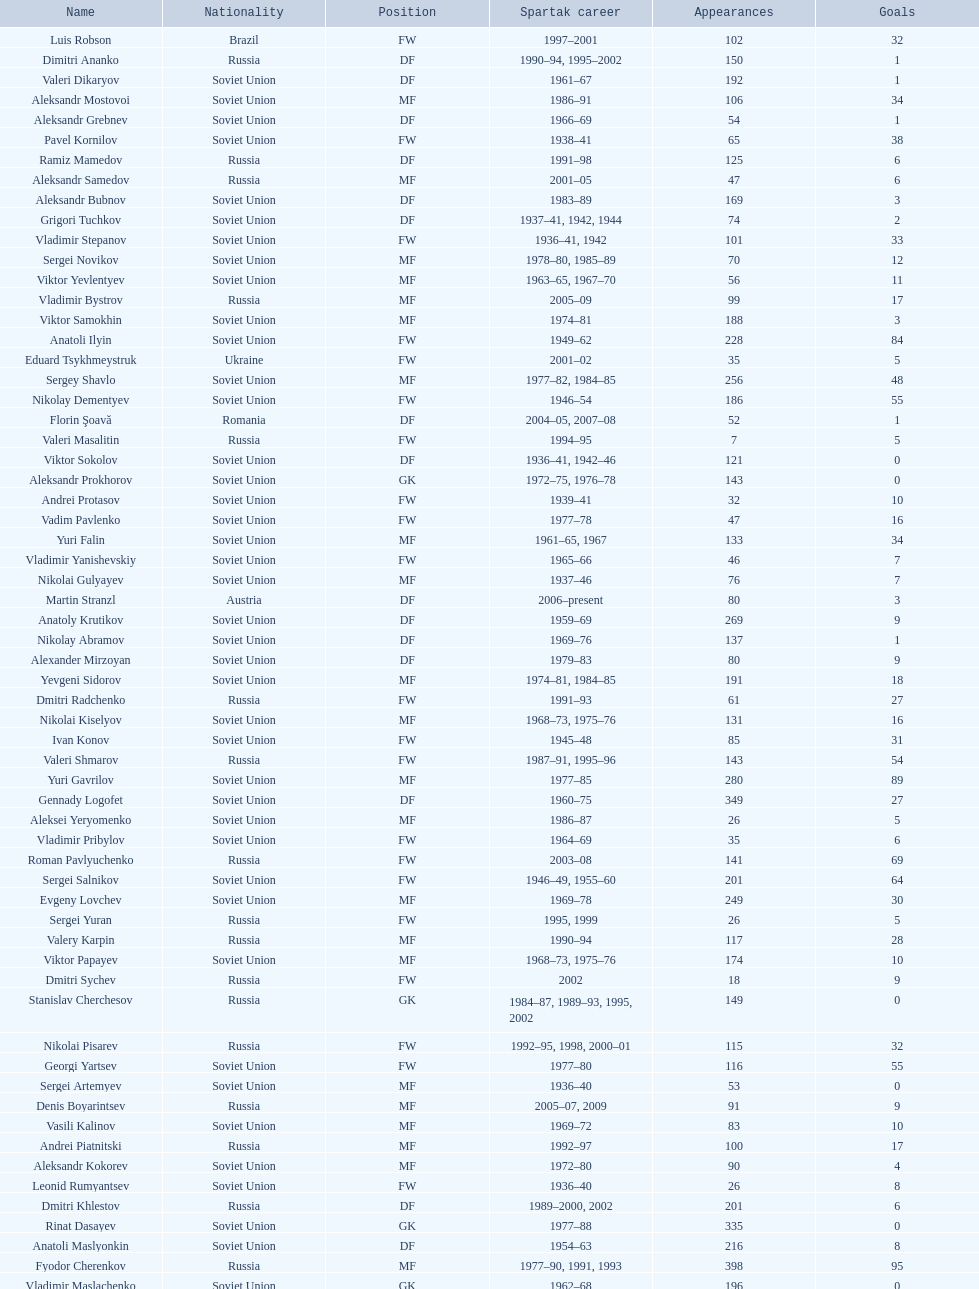Baranov has played from 2004 to the present. what is his nationality? Belarus. 